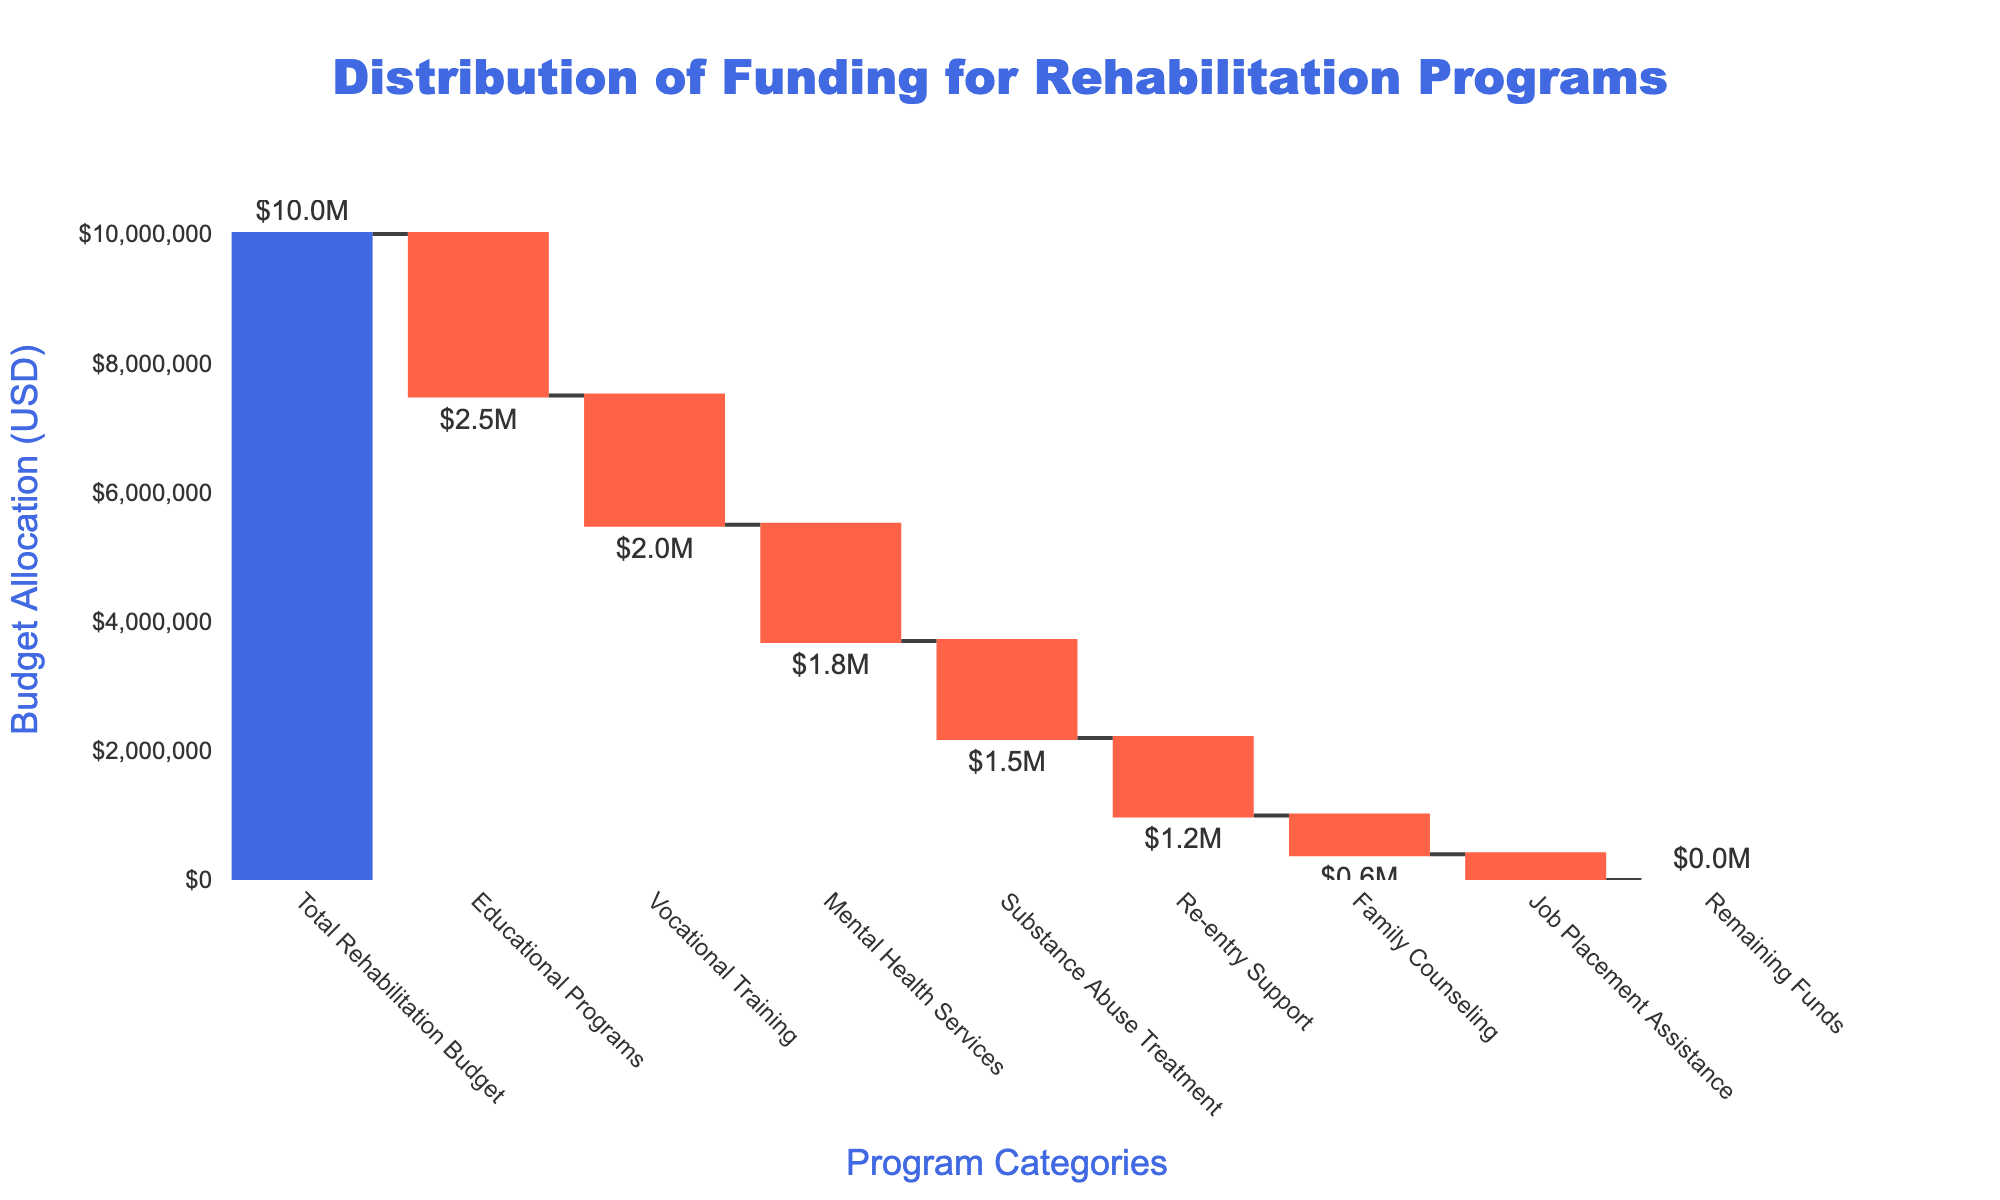What's the total rehabilitation budget? The total rehabilitation budget is the starting point of the waterfall chart. It's clearly labeled at the beginning of the plot as "Total Rehabilitation Budget".
Answer: $10,000,000 Which program has the highest funding allocation? By examining the waterfall chart, we can see the colored bars representing each program's funding. The longest bar on the negative side, indicating the most significant allocation, is for "Educational Programs".
Answer: Educational Programs How much funding is allocated for Mental Health Services? The length of the bar and the data label for Mental Health Services show a negative allocation, indicating $1.8 million.
Answer: $1,800,000 What color represents increasing and decreasing values in the chart? Increasing values are represented by green bars, and decreasing values are represented by red bars, as shown in the chart's color coding.
Answer: Green for increasing, red for decreasing What primary type of data is displayed on the y-axis? The y-axis displays the budget allocation in USD, as indicated by the y-axis title "Budget Allocation (USD)" and the tick format of currency.
Answer: Budget allocation in USD How much funding remains after all the programs are allocated? The last bar in the waterfall chart, labeled "Remaining Funds", represents the remaining budget, which is $0.
Answer: $0 Which program receives more funding: Vocational Training or Substance Abuse Treatment? By comparing the lengths of the corresponding bars, Vocational Training has a negative allocation of $2,000,000, while Substance Abuse Treatment has $1,500,000. Vocational Training receives more funding.
Answer: Vocational Training Calculate the total allocation for Educational Programs, Vocational Training, and Re-entry Support combined. Adding the allocations for Educational Programs (-$2,500,000), Vocational Training (-$2,000,000), and Re-entry Support (-$1,200,000): -2,500,000 - 2,000,000 - 1,200,000 = -5,700,000.
Answer: $5,700,000 Which allocation is closer to $600,000: Family Counseling or Job Placement Assistance? Family Counseling is allocated $600,000. Job Placement Assistance is allocated $400,000, which is further from $600,000.
Answer: Family Counseling 